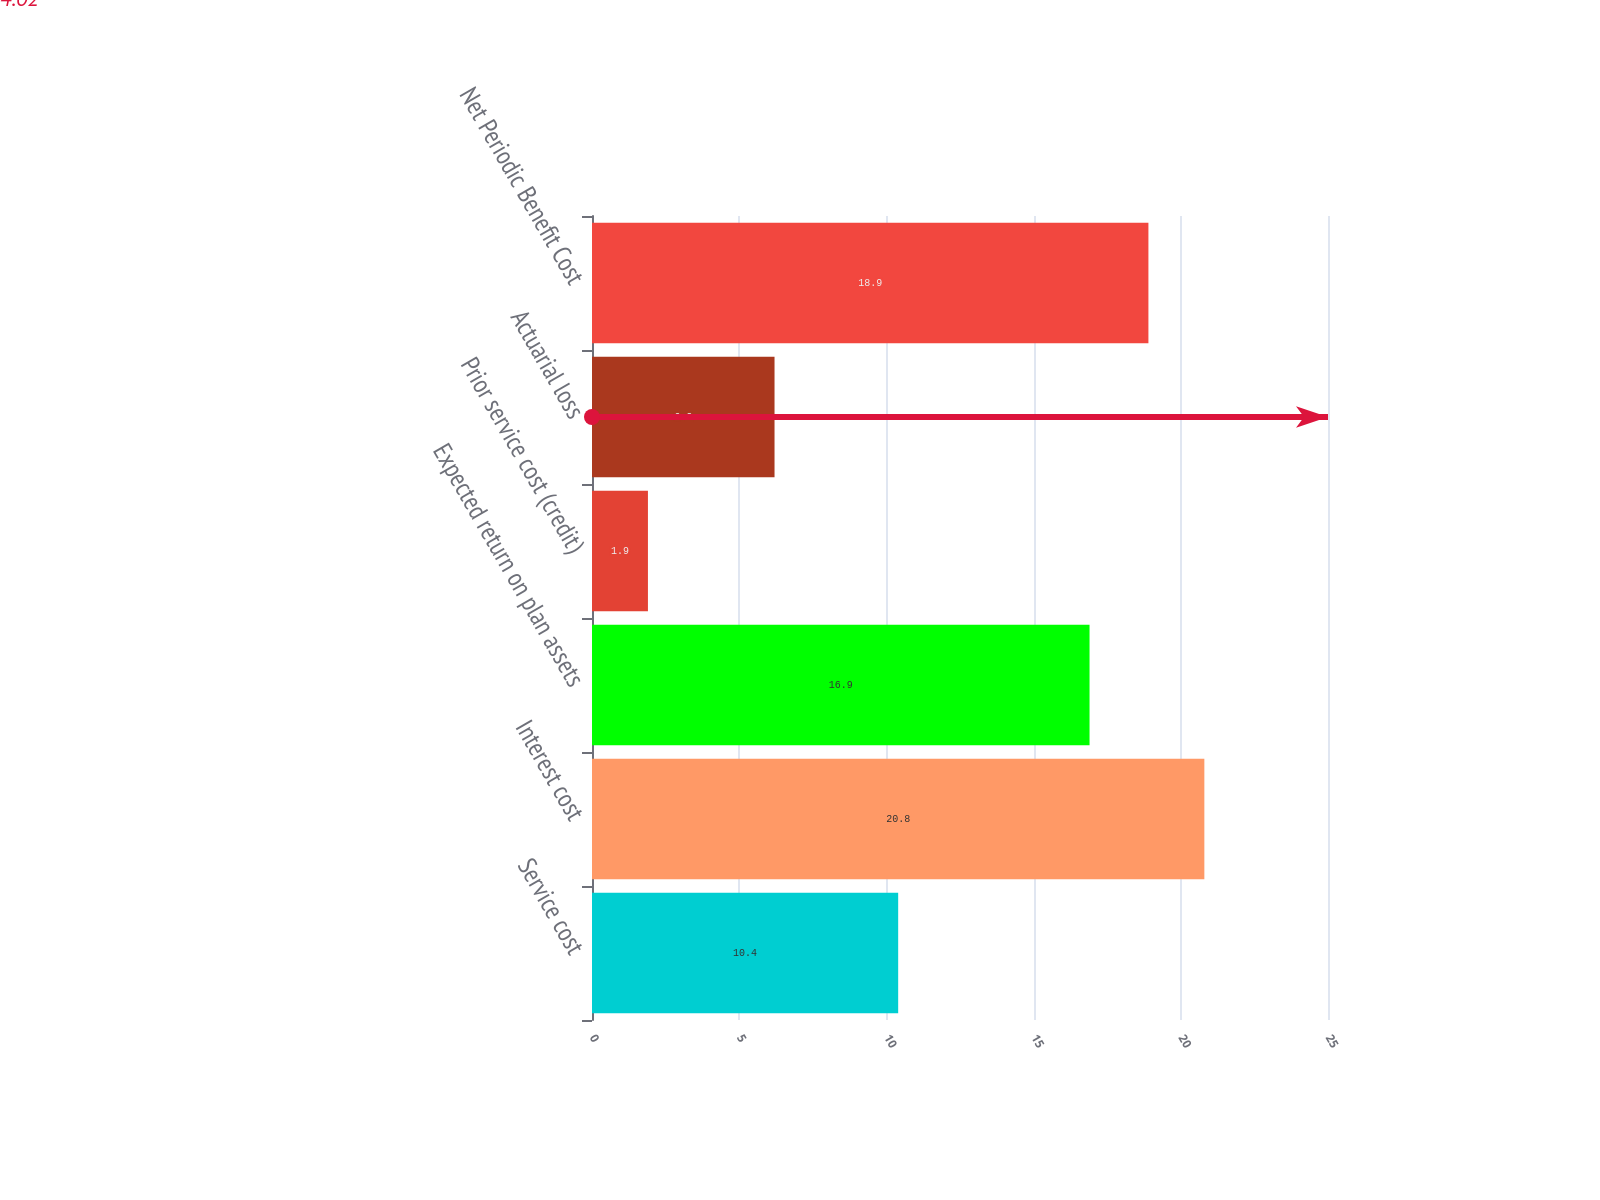Convert chart to OTSL. <chart><loc_0><loc_0><loc_500><loc_500><bar_chart><fcel>Service cost<fcel>Interest cost<fcel>Expected return on plan assets<fcel>Prior service cost (credit)<fcel>Actuarial loss<fcel>Net Periodic Benefit Cost<nl><fcel>10.4<fcel>20.8<fcel>16.9<fcel>1.9<fcel>6.2<fcel>18.9<nl></chart> 